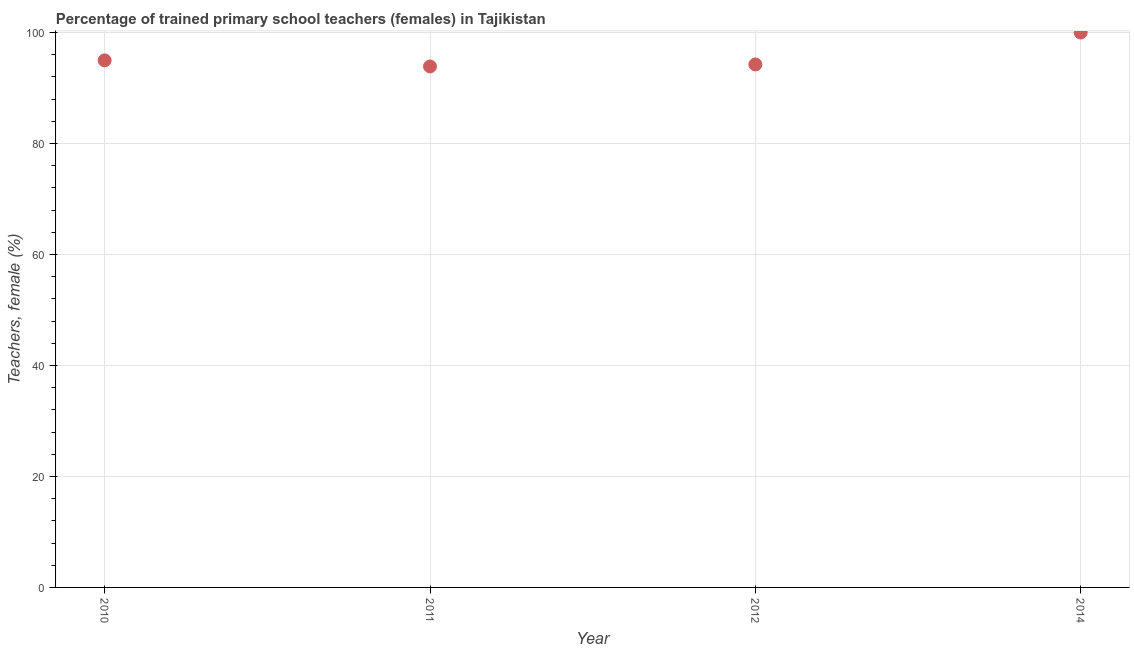Across all years, what is the maximum percentage of trained female teachers?
Keep it short and to the point. 100. Across all years, what is the minimum percentage of trained female teachers?
Your response must be concise. 93.88. In which year was the percentage of trained female teachers minimum?
Ensure brevity in your answer.  2011. What is the sum of the percentage of trained female teachers?
Provide a succinct answer. 383.11. What is the difference between the percentage of trained female teachers in 2012 and 2014?
Provide a succinct answer. -5.76. What is the average percentage of trained female teachers per year?
Provide a succinct answer. 95.78. What is the median percentage of trained female teachers?
Provide a short and direct response. 94.61. What is the ratio of the percentage of trained female teachers in 2010 to that in 2014?
Your answer should be very brief. 0.95. Is the percentage of trained female teachers in 2010 less than that in 2012?
Make the answer very short. No. What is the difference between the highest and the second highest percentage of trained female teachers?
Your response must be concise. 5.02. What is the difference between the highest and the lowest percentage of trained female teachers?
Make the answer very short. 6.12. Does the percentage of trained female teachers monotonically increase over the years?
Offer a terse response. No. How many dotlines are there?
Your answer should be compact. 1. How many years are there in the graph?
Keep it short and to the point. 4. Are the values on the major ticks of Y-axis written in scientific E-notation?
Provide a short and direct response. No. Does the graph contain any zero values?
Ensure brevity in your answer.  No. Does the graph contain grids?
Offer a very short reply. Yes. What is the title of the graph?
Make the answer very short. Percentage of trained primary school teachers (females) in Tajikistan. What is the label or title of the X-axis?
Keep it short and to the point. Year. What is the label or title of the Y-axis?
Your answer should be very brief. Teachers, female (%). What is the Teachers, female (%) in 2010?
Offer a very short reply. 94.98. What is the Teachers, female (%) in 2011?
Offer a terse response. 93.88. What is the Teachers, female (%) in 2012?
Provide a succinct answer. 94.24. What is the difference between the Teachers, female (%) in 2010 and 2011?
Provide a short and direct response. 1.1. What is the difference between the Teachers, female (%) in 2010 and 2012?
Ensure brevity in your answer.  0.74. What is the difference between the Teachers, female (%) in 2010 and 2014?
Ensure brevity in your answer.  -5.02. What is the difference between the Teachers, female (%) in 2011 and 2012?
Provide a short and direct response. -0.36. What is the difference between the Teachers, female (%) in 2011 and 2014?
Ensure brevity in your answer.  -6.12. What is the difference between the Teachers, female (%) in 2012 and 2014?
Give a very brief answer. -5.76. What is the ratio of the Teachers, female (%) in 2010 to that in 2014?
Keep it short and to the point. 0.95. What is the ratio of the Teachers, female (%) in 2011 to that in 2014?
Offer a very short reply. 0.94. What is the ratio of the Teachers, female (%) in 2012 to that in 2014?
Your answer should be very brief. 0.94. 